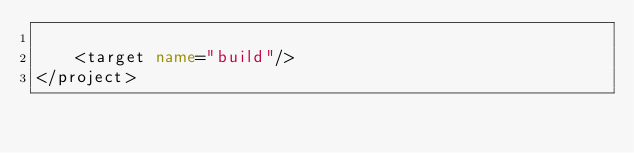<code> <loc_0><loc_0><loc_500><loc_500><_XML_>
    <target name="build"/>
</project>
</code> 